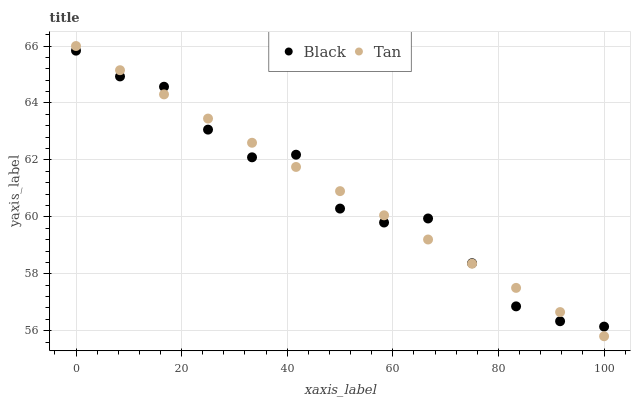Does Black have the minimum area under the curve?
Answer yes or no. Yes. Does Tan have the maximum area under the curve?
Answer yes or no. Yes. Does Black have the maximum area under the curve?
Answer yes or no. No. Is Tan the smoothest?
Answer yes or no. Yes. Is Black the roughest?
Answer yes or no. Yes. Is Black the smoothest?
Answer yes or no. No. Does Tan have the lowest value?
Answer yes or no. Yes. Does Black have the lowest value?
Answer yes or no. No. Does Tan have the highest value?
Answer yes or no. Yes. Does Black have the highest value?
Answer yes or no. No. Does Black intersect Tan?
Answer yes or no. Yes. Is Black less than Tan?
Answer yes or no. No. Is Black greater than Tan?
Answer yes or no. No. 